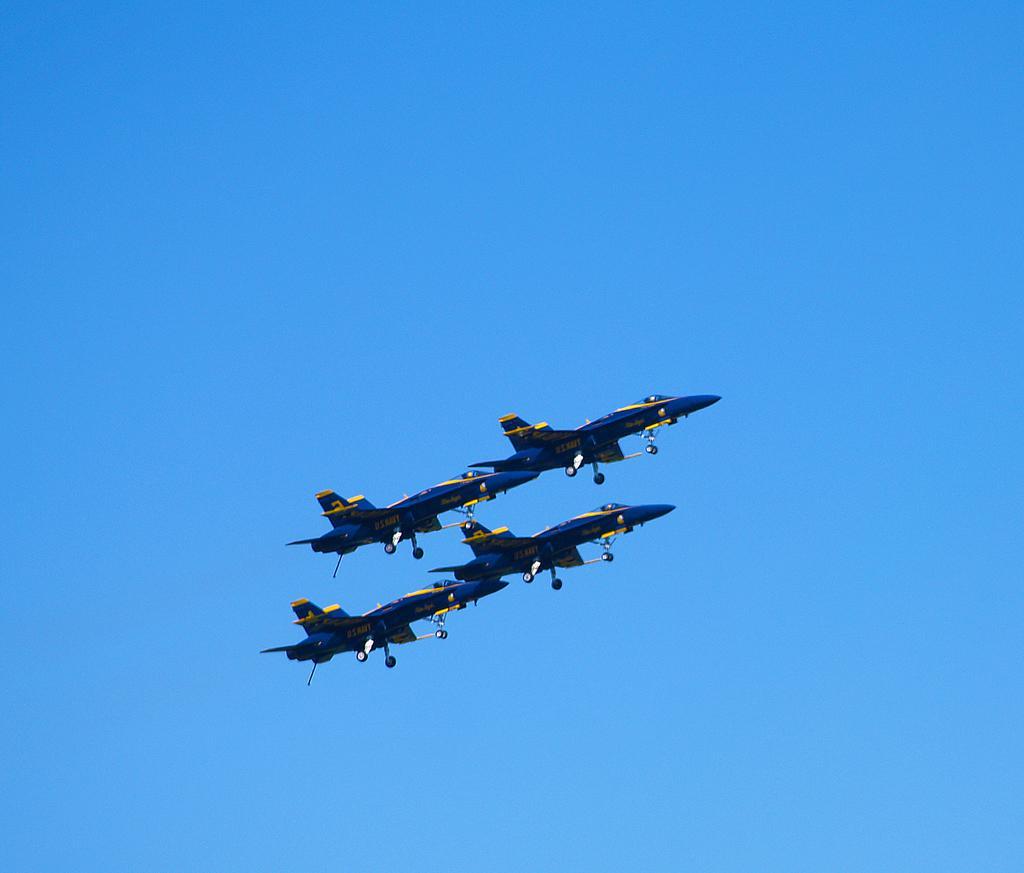Could you give a brief overview of what you see in this image? In the middle of the image we can see few jet planes in the air. 